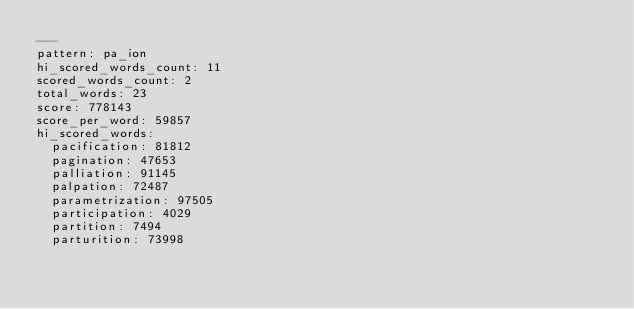Convert code to text. <code><loc_0><loc_0><loc_500><loc_500><_YAML_>---
pattern: pa_ion
hi_scored_words_count: 11
scored_words_count: 2
total_words: 23
score: 778143
score_per_word: 59857
hi_scored_words:
  pacification: 81812
  pagination: 47653
  palliation: 91145
  palpation: 72487
  parametrization: 97505
  participation: 4029
  partition: 7494
  parturition: 73998</code> 